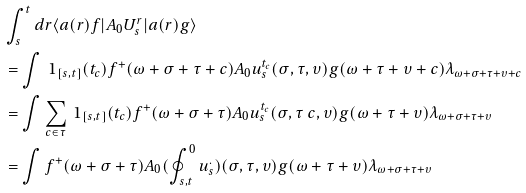Convert formula to latex. <formula><loc_0><loc_0><loc_500><loc_500>& \int _ { s } ^ { t } d r \langle a ( r ) f | A _ { 0 } U ^ { r } _ { s } | a ( r ) g \rangle \\ & = \int \ 1 _ { [ s , t ] } ( t _ { c } ) f ^ { + } ( \omega + \sigma + \tau + c ) A _ { 0 } u _ { s } ^ { t _ { c } } ( \sigma , \tau , \upsilon ) g ( \omega + \tau + \upsilon + c ) \lambda _ { \omega + \sigma + \tau + \upsilon + c } \\ & = \int \sum _ { c \in \tau } \ 1 _ { [ s , t ] } ( t _ { c } ) f ^ { + } ( \omega + \sigma + \tau ) A _ { 0 } u _ { s } ^ { t _ { c } } ( \sigma , \tau \ c , \upsilon ) g ( \omega + \tau + \upsilon ) \lambda _ { \omega + \sigma + \tau + \upsilon } \\ & = \int f ^ { + } ( \omega + \sigma + \tau ) A _ { 0 } ( \oint ^ { 0 } _ { s , t } u _ { s } ^ { . } ) ( \sigma , \tau , \upsilon ) g ( \omega + \tau + \upsilon ) \lambda _ { \omega + \sigma + \tau + \upsilon }</formula> 